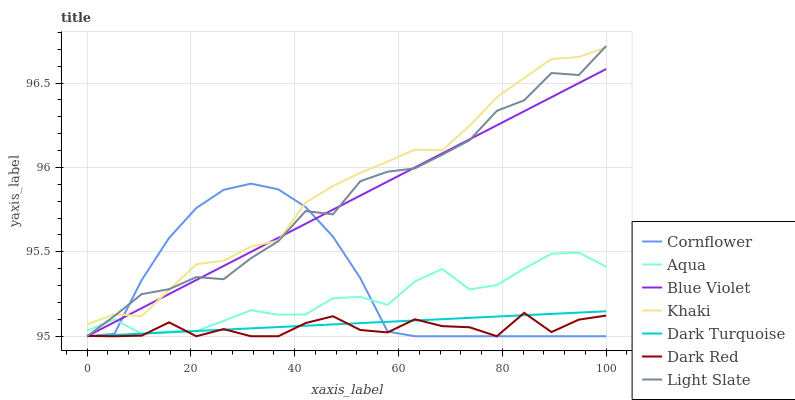Does Dark Red have the minimum area under the curve?
Answer yes or no. Yes. Does Khaki have the maximum area under the curve?
Answer yes or no. Yes. Does Light Slate have the minimum area under the curve?
Answer yes or no. No. Does Light Slate have the maximum area under the curve?
Answer yes or no. No. Is Dark Turquoise the smoothest?
Answer yes or no. Yes. Is Light Slate the roughest?
Answer yes or no. Yes. Is Khaki the smoothest?
Answer yes or no. No. Is Khaki the roughest?
Answer yes or no. No. Does Cornflower have the lowest value?
Answer yes or no. Yes. Does Khaki have the lowest value?
Answer yes or no. No. Does Light Slate have the highest value?
Answer yes or no. Yes. Does Khaki have the highest value?
Answer yes or no. No. Is Dark Red less than Khaki?
Answer yes or no. Yes. Is Khaki greater than Aqua?
Answer yes or no. Yes. Does Light Slate intersect Blue Violet?
Answer yes or no. Yes. Is Light Slate less than Blue Violet?
Answer yes or no. No. Is Light Slate greater than Blue Violet?
Answer yes or no. No. Does Dark Red intersect Khaki?
Answer yes or no. No. 